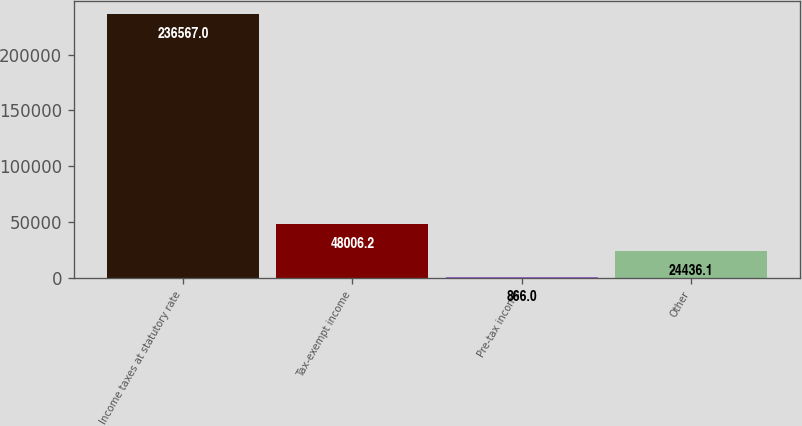<chart> <loc_0><loc_0><loc_500><loc_500><bar_chart><fcel>Income taxes at statutory rate<fcel>Tax-exempt income<fcel>Pre-tax income<fcel>Other<nl><fcel>236567<fcel>48006.2<fcel>866<fcel>24436.1<nl></chart> 